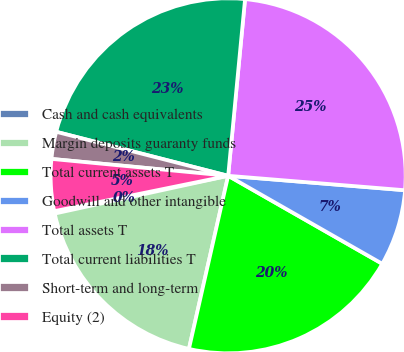Convert chart to OTSL. <chart><loc_0><loc_0><loc_500><loc_500><pie_chart><fcel>Cash and cash equivalents<fcel>Margin deposits guaranty funds<fcel>Total current assets T<fcel>Goodwill and other intangible<fcel>Total assets T<fcel>Total current liabilities T<fcel>Short-term and long-term<fcel>Equity (2)<nl><fcel>0.22%<fcel>18.04%<fcel>20.29%<fcel>6.96%<fcel>24.78%<fcel>22.53%<fcel>2.47%<fcel>4.71%<nl></chart> 